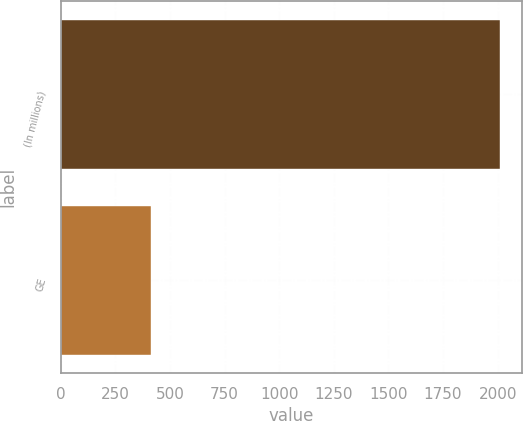<chart> <loc_0><loc_0><loc_500><loc_500><bar_chart><fcel>(In millions)<fcel>GE<nl><fcel>2012<fcel>414<nl></chart> 